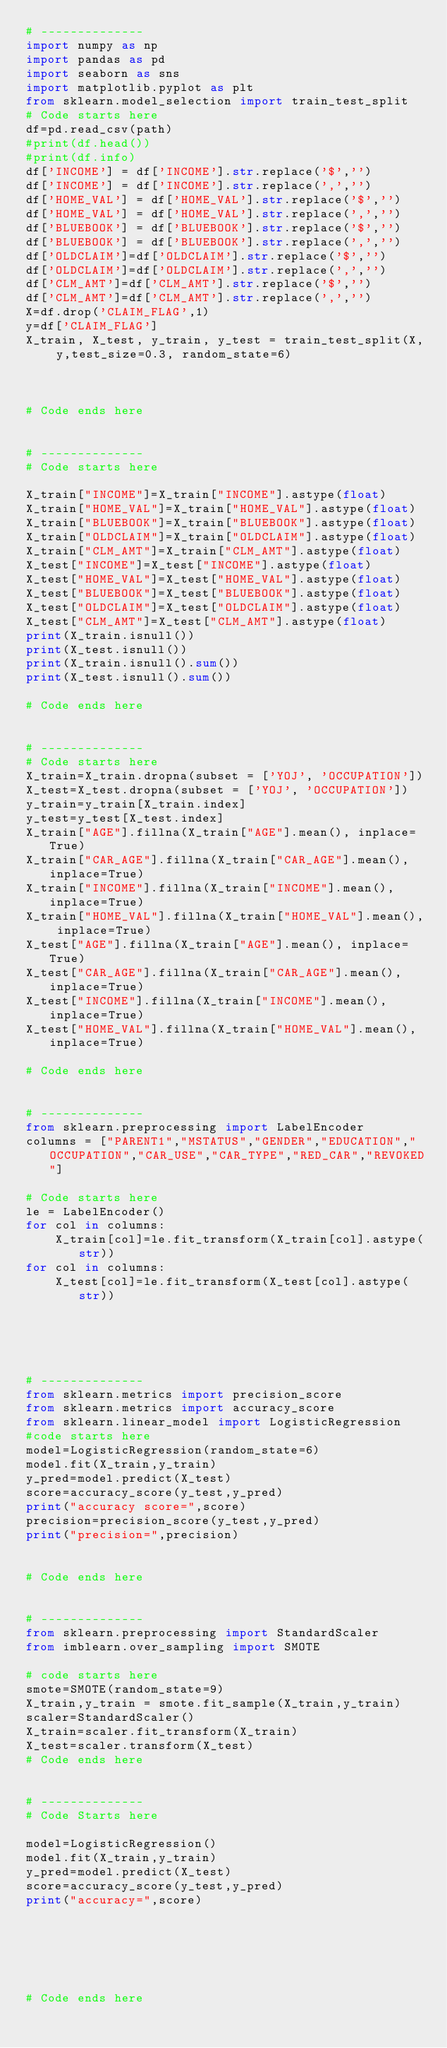<code> <loc_0><loc_0><loc_500><loc_500><_Python_># --------------
import numpy as np
import pandas as pd
import seaborn as sns
import matplotlib.pyplot as plt
from sklearn.model_selection import train_test_split
# Code starts here
df=pd.read_csv(path)
#print(df.head())
#print(df.info)
df['INCOME'] = df['INCOME'].str.replace('$','')
df['INCOME'] = df['INCOME'].str.replace(',','')
df['HOME_VAL'] = df['HOME_VAL'].str.replace('$','')
df['HOME_VAL'] = df['HOME_VAL'].str.replace(',','')
df['BLUEBOOK'] = df['BLUEBOOK'].str.replace('$','')
df['BLUEBOOK'] = df['BLUEBOOK'].str.replace(',','')
df['OLDCLAIM']=df['OLDCLAIM'].str.replace('$','')
df['OLDCLAIM']=df['OLDCLAIM'].str.replace(',','')
df['CLM_AMT']=df['CLM_AMT'].str.replace('$','')
df['CLM_AMT']=df['CLM_AMT'].str.replace(',','')
X=df.drop('CLAIM_FLAG',1)
y=df['CLAIM_FLAG']
X_train, X_test, y_train, y_test = train_test_split(X, y,test_size=0.3, random_state=6)



# Code ends here


# --------------
# Code starts here

X_train["INCOME"]=X_train["INCOME"].astype(float)
X_train["HOME_VAL"]=X_train["HOME_VAL"].astype(float)
X_train["BLUEBOOK"]=X_train["BLUEBOOK"].astype(float)
X_train["OLDCLAIM"]=X_train["OLDCLAIM"].astype(float)
X_train["CLM_AMT"]=X_train["CLM_AMT"].astype(float)
X_test["INCOME"]=X_test["INCOME"].astype(float)
X_test["HOME_VAL"]=X_test["HOME_VAL"].astype(float)
X_test["BLUEBOOK"]=X_test["BLUEBOOK"].astype(float)
X_test["OLDCLAIM"]=X_test["OLDCLAIM"].astype(float)
X_test["CLM_AMT"]=X_test["CLM_AMT"].astype(float)
print(X_train.isnull())
print(X_test.isnull())
print(X_train.isnull().sum())
print(X_test.isnull().sum())

# Code ends here


# --------------
# Code starts here
X_train=X_train.dropna(subset = ['YOJ', 'OCCUPATION'])
X_test=X_test.dropna(subset = ['YOJ', 'OCCUPATION'])
y_train=y_train[X_train.index]
y_test=y_test[X_test.index]
X_train["AGE"].fillna(X_train["AGE"].mean(), inplace=True)
X_train["CAR_AGE"].fillna(X_train["CAR_AGE"].mean(), inplace=True)
X_train["INCOME"].fillna(X_train["INCOME"].mean(), inplace=True)
X_train["HOME_VAL"].fillna(X_train["HOME_VAL"].mean(), inplace=True)
X_test["AGE"].fillna(X_train["AGE"].mean(), inplace=True)
X_test["CAR_AGE"].fillna(X_train["CAR_AGE"].mean(), inplace=True)
X_test["INCOME"].fillna(X_train["INCOME"].mean(), inplace=True)
X_test["HOME_VAL"].fillna(X_train["HOME_VAL"].mean(), inplace=True)

# Code ends here


# --------------
from sklearn.preprocessing import LabelEncoder
columns = ["PARENT1","MSTATUS","GENDER","EDUCATION","OCCUPATION","CAR_USE","CAR_TYPE","RED_CAR","REVOKED"]

# Code starts here
le = LabelEncoder()
for col in columns:
    X_train[col]=le.fit_transform(X_train[col].astype(str))
for col in columns:
    X_test[col]=le.fit_transform(X_test[col].astype(str))





# --------------
from sklearn.metrics import precision_score 
from sklearn.metrics import accuracy_score
from sklearn.linear_model import LogisticRegression
#code starts here 
model=LogisticRegression(random_state=6)
model.fit(X_train,y_train)
y_pred=model.predict(X_test)
score=accuracy_score(y_test,y_pred)
print("accuracy score=",score)
precision=precision_score(y_test,y_pred)
print("precision=",precision)


# Code ends here


# --------------
from sklearn.preprocessing import StandardScaler
from imblearn.over_sampling import SMOTE

# code starts here
smote=SMOTE(random_state=9)
X_train,y_train = smote.fit_sample(X_train,y_train)
scaler=StandardScaler()
X_train=scaler.fit_transform(X_train)
X_test=scaler.transform(X_test)
# Code ends here


# --------------
# Code Starts here

model=LogisticRegression()
model.fit(X_train,y_train)
y_pred=model.predict(X_test)
score=accuracy_score(y_test,y_pred)
print("accuracy=",score)






# Code ends here


</code> 